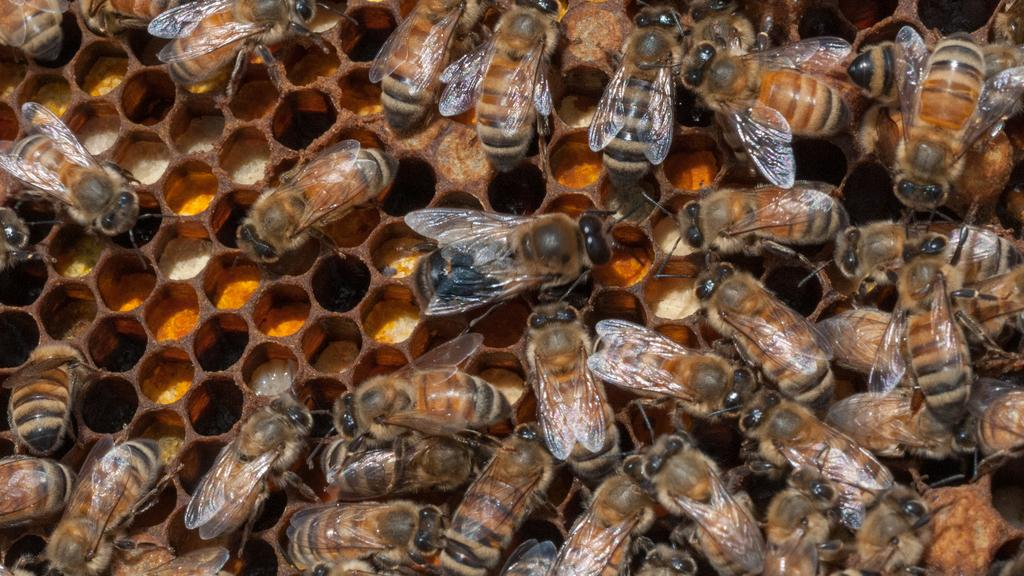What type of insects are present in the image? There are honey bees in the image. Where are the honey bees located? The honey bees are on a honeycomb. What type of suit is the honey bee wearing in the image? There are no suits present in the image, as honey bees are insects and do not wear clothing. 